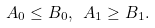<formula> <loc_0><loc_0><loc_500><loc_500>A _ { 0 } \leq B _ { 0 } , \ A _ { 1 } \geq B _ { 1 } .</formula> 